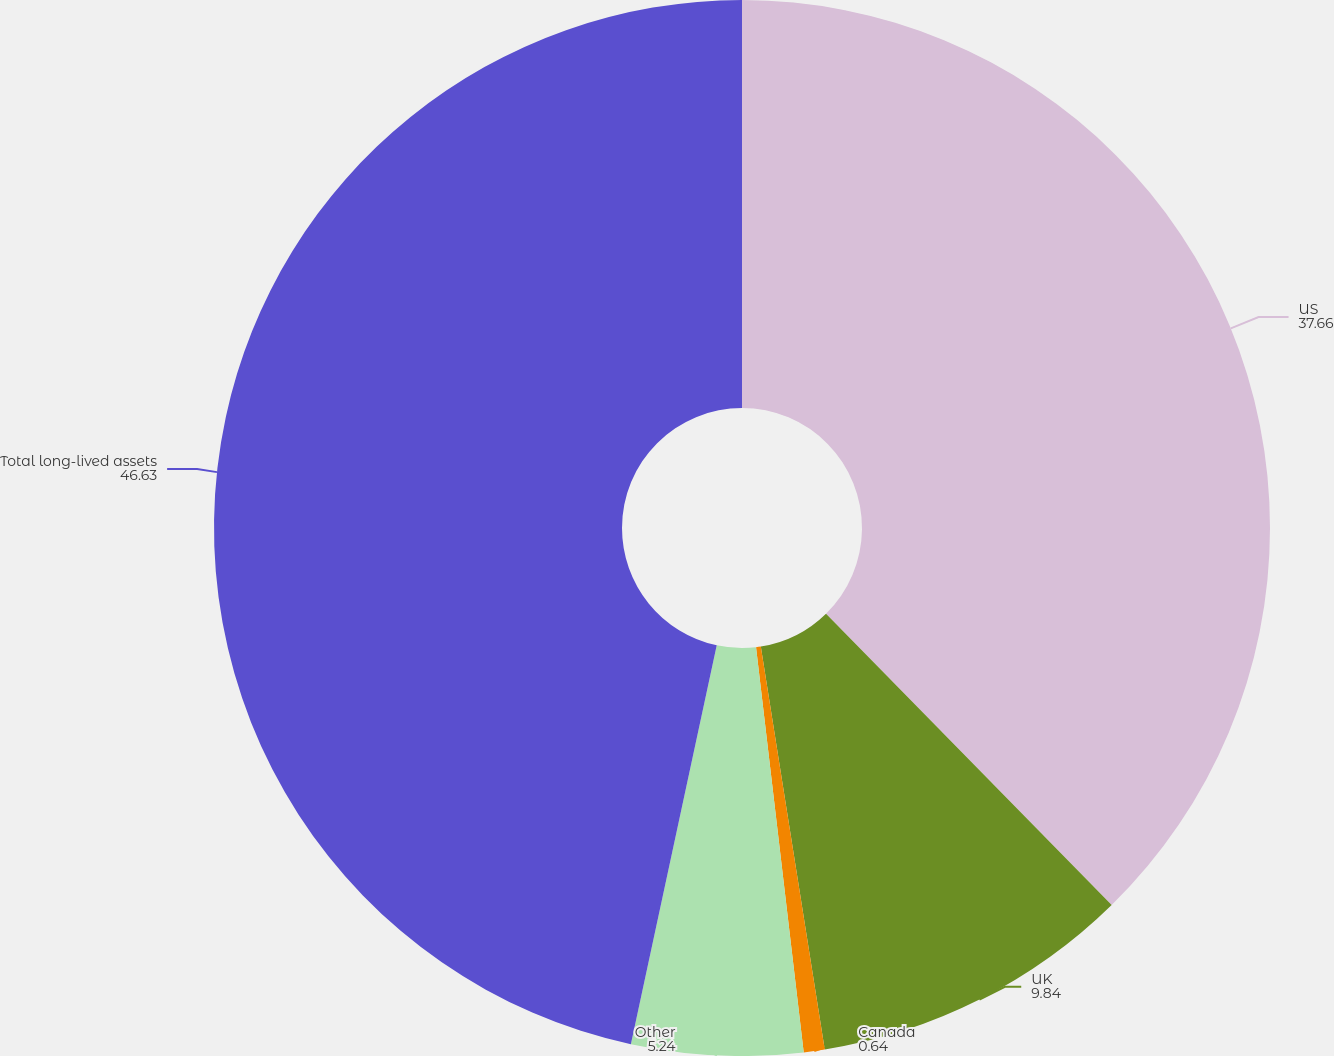Convert chart to OTSL. <chart><loc_0><loc_0><loc_500><loc_500><pie_chart><fcel>US<fcel>UK<fcel>Canada<fcel>Other<fcel>Total long-lived assets<nl><fcel>37.66%<fcel>9.84%<fcel>0.64%<fcel>5.24%<fcel>46.63%<nl></chart> 